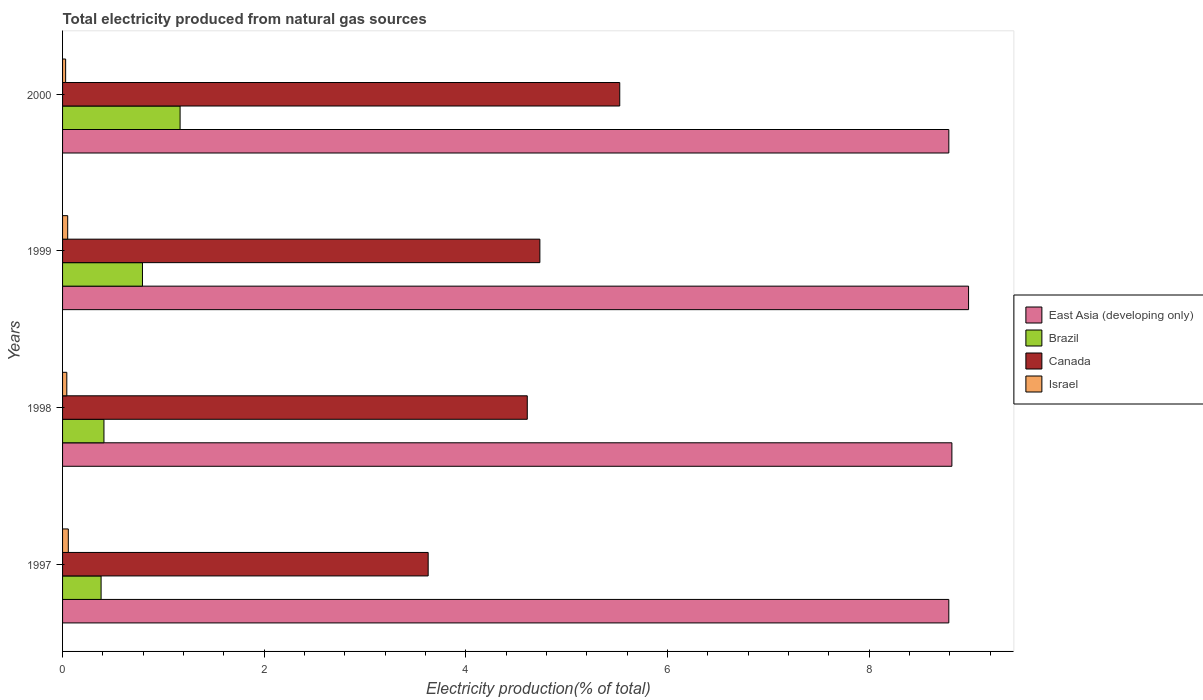How many different coloured bars are there?
Your answer should be compact. 4. How many groups of bars are there?
Your answer should be compact. 4. How many bars are there on the 3rd tick from the bottom?
Keep it short and to the point. 4. What is the total electricity produced in Canada in 1999?
Make the answer very short. 4.73. Across all years, what is the maximum total electricity produced in East Asia (developing only)?
Provide a short and direct response. 8.99. Across all years, what is the minimum total electricity produced in East Asia (developing only)?
Ensure brevity in your answer.  8.79. In which year was the total electricity produced in East Asia (developing only) maximum?
Your response must be concise. 1999. What is the total total electricity produced in Israel in the graph?
Ensure brevity in your answer.  0.18. What is the difference between the total electricity produced in Canada in 1998 and that in 1999?
Provide a succinct answer. -0.13. What is the difference between the total electricity produced in Israel in 1997 and the total electricity produced in Brazil in 1999?
Your response must be concise. -0.74. What is the average total electricity produced in Brazil per year?
Ensure brevity in your answer.  0.69. In the year 1997, what is the difference between the total electricity produced in Brazil and total electricity produced in East Asia (developing only)?
Make the answer very short. -8.41. In how many years, is the total electricity produced in Israel greater than 2 %?
Give a very brief answer. 0. What is the ratio of the total electricity produced in Brazil in 1999 to that in 2000?
Make the answer very short. 0.68. Is the difference between the total electricity produced in Brazil in 1997 and 1998 greater than the difference between the total electricity produced in East Asia (developing only) in 1997 and 1998?
Provide a short and direct response. Yes. What is the difference between the highest and the second highest total electricity produced in Brazil?
Make the answer very short. 0.37. What is the difference between the highest and the lowest total electricity produced in Canada?
Offer a very short reply. 1.9. In how many years, is the total electricity produced in Brazil greater than the average total electricity produced in Brazil taken over all years?
Give a very brief answer. 2. Is the sum of the total electricity produced in Canada in 1997 and 1999 greater than the maximum total electricity produced in Israel across all years?
Provide a short and direct response. Yes. Is it the case that in every year, the sum of the total electricity produced in Brazil and total electricity produced in Israel is greater than the sum of total electricity produced in East Asia (developing only) and total electricity produced in Canada?
Your answer should be compact. No. What does the 3rd bar from the top in 1997 represents?
Your response must be concise. Brazil. Is it the case that in every year, the sum of the total electricity produced in Brazil and total electricity produced in East Asia (developing only) is greater than the total electricity produced in Israel?
Provide a succinct answer. Yes. How many bars are there?
Make the answer very short. 16. Are all the bars in the graph horizontal?
Your answer should be compact. Yes. How many years are there in the graph?
Provide a succinct answer. 4. Are the values on the major ticks of X-axis written in scientific E-notation?
Your answer should be very brief. No. Does the graph contain grids?
Ensure brevity in your answer.  No. How many legend labels are there?
Keep it short and to the point. 4. How are the legend labels stacked?
Offer a terse response. Vertical. What is the title of the graph?
Provide a succinct answer. Total electricity produced from natural gas sources. What is the Electricity production(% of total) of East Asia (developing only) in 1997?
Ensure brevity in your answer.  8.79. What is the Electricity production(% of total) in Brazil in 1997?
Provide a short and direct response. 0.38. What is the Electricity production(% of total) of Canada in 1997?
Your answer should be very brief. 3.63. What is the Electricity production(% of total) of Israel in 1997?
Make the answer very short. 0.06. What is the Electricity production(% of total) of East Asia (developing only) in 1998?
Make the answer very short. 8.82. What is the Electricity production(% of total) in Brazil in 1998?
Your answer should be very brief. 0.41. What is the Electricity production(% of total) in Canada in 1998?
Give a very brief answer. 4.61. What is the Electricity production(% of total) in Israel in 1998?
Offer a terse response. 0.04. What is the Electricity production(% of total) in East Asia (developing only) in 1999?
Keep it short and to the point. 8.99. What is the Electricity production(% of total) in Brazil in 1999?
Keep it short and to the point. 0.79. What is the Electricity production(% of total) of Canada in 1999?
Offer a terse response. 4.73. What is the Electricity production(% of total) of Israel in 1999?
Keep it short and to the point. 0.05. What is the Electricity production(% of total) of East Asia (developing only) in 2000?
Offer a terse response. 8.79. What is the Electricity production(% of total) in Brazil in 2000?
Offer a very short reply. 1.17. What is the Electricity production(% of total) of Canada in 2000?
Provide a short and direct response. 5.53. What is the Electricity production(% of total) in Israel in 2000?
Ensure brevity in your answer.  0.03. Across all years, what is the maximum Electricity production(% of total) in East Asia (developing only)?
Give a very brief answer. 8.99. Across all years, what is the maximum Electricity production(% of total) of Brazil?
Your answer should be compact. 1.17. Across all years, what is the maximum Electricity production(% of total) of Canada?
Make the answer very short. 5.53. Across all years, what is the maximum Electricity production(% of total) of Israel?
Offer a very short reply. 0.06. Across all years, what is the minimum Electricity production(% of total) in East Asia (developing only)?
Give a very brief answer. 8.79. Across all years, what is the minimum Electricity production(% of total) of Brazil?
Ensure brevity in your answer.  0.38. Across all years, what is the minimum Electricity production(% of total) in Canada?
Offer a very short reply. 3.63. Across all years, what is the minimum Electricity production(% of total) of Israel?
Your response must be concise. 0.03. What is the total Electricity production(% of total) of East Asia (developing only) in the graph?
Your response must be concise. 35.39. What is the total Electricity production(% of total) in Brazil in the graph?
Offer a terse response. 2.75. What is the total Electricity production(% of total) in Canada in the graph?
Provide a succinct answer. 18.5. What is the total Electricity production(% of total) of Israel in the graph?
Keep it short and to the point. 0.18. What is the difference between the Electricity production(% of total) of East Asia (developing only) in 1997 and that in 1998?
Offer a terse response. -0.03. What is the difference between the Electricity production(% of total) of Brazil in 1997 and that in 1998?
Give a very brief answer. -0.03. What is the difference between the Electricity production(% of total) of Canada in 1997 and that in 1998?
Your response must be concise. -0.98. What is the difference between the Electricity production(% of total) in Israel in 1997 and that in 1998?
Provide a short and direct response. 0.01. What is the difference between the Electricity production(% of total) of East Asia (developing only) in 1997 and that in 1999?
Ensure brevity in your answer.  -0.2. What is the difference between the Electricity production(% of total) in Brazil in 1997 and that in 1999?
Your answer should be compact. -0.41. What is the difference between the Electricity production(% of total) in Canada in 1997 and that in 1999?
Provide a short and direct response. -1.11. What is the difference between the Electricity production(% of total) of Israel in 1997 and that in 1999?
Give a very brief answer. 0.01. What is the difference between the Electricity production(% of total) of East Asia (developing only) in 1997 and that in 2000?
Your answer should be very brief. -0. What is the difference between the Electricity production(% of total) in Brazil in 1997 and that in 2000?
Offer a very short reply. -0.78. What is the difference between the Electricity production(% of total) in Canada in 1997 and that in 2000?
Give a very brief answer. -1.9. What is the difference between the Electricity production(% of total) in Israel in 1997 and that in 2000?
Keep it short and to the point. 0.03. What is the difference between the Electricity production(% of total) in East Asia (developing only) in 1998 and that in 1999?
Your answer should be compact. -0.17. What is the difference between the Electricity production(% of total) of Brazil in 1998 and that in 1999?
Provide a succinct answer. -0.38. What is the difference between the Electricity production(% of total) of Canada in 1998 and that in 1999?
Provide a succinct answer. -0.12. What is the difference between the Electricity production(% of total) of Israel in 1998 and that in 1999?
Ensure brevity in your answer.  -0.01. What is the difference between the Electricity production(% of total) in East Asia (developing only) in 1998 and that in 2000?
Your answer should be very brief. 0.03. What is the difference between the Electricity production(% of total) in Brazil in 1998 and that in 2000?
Your response must be concise. -0.76. What is the difference between the Electricity production(% of total) of Canada in 1998 and that in 2000?
Your answer should be compact. -0.92. What is the difference between the Electricity production(% of total) of Israel in 1998 and that in 2000?
Provide a succinct answer. 0.01. What is the difference between the Electricity production(% of total) of East Asia (developing only) in 1999 and that in 2000?
Provide a short and direct response. 0.2. What is the difference between the Electricity production(% of total) of Brazil in 1999 and that in 2000?
Give a very brief answer. -0.37. What is the difference between the Electricity production(% of total) of Canada in 1999 and that in 2000?
Ensure brevity in your answer.  -0.79. What is the difference between the Electricity production(% of total) of Israel in 1999 and that in 2000?
Keep it short and to the point. 0.02. What is the difference between the Electricity production(% of total) of East Asia (developing only) in 1997 and the Electricity production(% of total) of Brazil in 1998?
Your answer should be compact. 8.38. What is the difference between the Electricity production(% of total) of East Asia (developing only) in 1997 and the Electricity production(% of total) of Canada in 1998?
Your answer should be compact. 4.18. What is the difference between the Electricity production(% of total) of East Asia (developing only) in 1997 and the Electricity production(% of total) of Israel in 1998?
Offer a very short reply. 8.75. What is the difference between the Electricity production(% of total) of Brazil in 1997 and the Electricity production(% of total) of Canada in 1998?
Offer a terse response. -4.23. What is the difference between the Electricity production(% of total) of Brazil in 1997 and the Electricity production(% of total) of Israel in 1998?
Your answer should be very brief. 0.34. What is the difference between the Electricity production(% of total) of Canada in 1997 and the Electricity production(% of total) of Israel in 1998?
Offer a terse response. 3.58. What is the difference between the Electricity production(% of total) of East Asia (developing only) in 1997 and the Electricity production(% of total) of Brazil in 1999?
Offer a terse response. 8. What is the difference between the Electricity production(% of total) of East Asia (developing only) in 1997 and the Electricity production(% of total) of Canada in 1999?
Your response must be concise. 4.06. What is the difference between the Electricity production(% of total) in East Asia (developing only) in 1997 and the Electricity production(% of total) in Israel in 1999?
Give a very brief answer. 8.74. What is the difference between the Electricity production(% of total) in Brazil in 1997 and the Electricity production(% of total) in Canada in 1999?
Ensure brevity in your answer.  -4.35. What is the difference between the Electricity production(% of total) of Brazil in 1997 and the Electricity production(% of total) of Israel in 1999?
Offer a terse response. 0.33. What is the difference between the Electricity production(% of total) of Canada in 1997 and the Electricity production(% of total) of Israel in 1999?
Keep it short and to the point. 3.58. What is the difference between the Electricity production(% of total) in East Asia (developing only) in 1997 and the Electricity production(% of total) in Brazil in 2000?
Provide a succinct answer. 7.63. What is the difference between the Electricity production(% of total) of East Asia (developing only) in 1997 and the Electricity production(% of total) of Canada in 2000?
Provide a succinct answer. 3.26. What is the difference between the Electricity production(% of total) of East Asia (developing only) in 1997 and the Electricity production(% of total) of Israel in 2000?
Your answer should be very brief. 8.76. What is the difference between the Electricity production(% of total) in Brazil in 1997 and the Electricity production(% of total) in Canada in 2000?
Offer a terse response. -5.14. What is the difference between the Electricity production(% of total) of Brazil in 1997 and the Electricity production(% of total) of Israel in 2000?
Ensure brevity in your answer.  0.35. What is the difference between the Electricity production(% of total) in Canada in 1997 and the Electricity production(% of total) in Israel in 2000?
Keep it short and to the point. 3.6. What is the difference between the Electricity production(% of total) in East Asia (developing only) in 1998 and the Electricity production(% of total) in Brazil in 1999?
Ensure brevity in your answer.  8.03. What is the difference between the Electricity production(% of total) of East Asia (developing only) in 1998 and the Electricity production(% of total) of Canada in 1999?
Your answer should be very brief. 4.09. What is the difference between the Electricity production(% of total) in East Asia (developing only) in 1998 and the Electricity production(% of total) in Israel in 1999?
Provide a short and direct response. 8.77. What is the difference between the Electricity production(% of total) of Brazil in 1998 and the Electricity production(% of total) of Canada in 1999?
Give a very brief answer. -4.32. What is the difference between the Electricity production(% of total) of Brazil in 1998 and the Electricity production(% of total) of Israel in 1999?
Your answer should be very brief. 0.36. What is the difference between the Electricity production(% of total) of Canada in 1998 and the Electricity production(% of total) of Israel in 1999?
Provide a short and direct response. 4.56. What is the difference between the Electricity production(% of total) in East Asia (developing only) in 1998 and the Electricity production(% of total) in Brazil in 2000?
Your answer should be very brief. 7.66. What is the difference between the Electricity production(% of total) in East Asia (developing only) in 1998 and the Electricity production(% of total) in Canada in 2000?
Provide a succinct answer. 3.29. What is the difference between the Electricity production(% of total) in East Asia (developing only) in 1998 and the Electricity production(% of total) in Israel in 2000?
Ensure brevity in your answer.  8.79. What is the difference between the Electricity production(% of total) in Brazil in 1998 and the Electricity production(% of total) in Canada in 2000?
Offer a terse response. -5.12. What is the difference between the Electricity production(% of total) of Brazil in 1998 and the Electricity production(% of total) of Israel in 2000?
Keep it short and to the point. 0.38. What is the difference between the Electricity production(% of total) in Canada in 1998 and the Electricity production(% of total) in Israel in 2000?
Your answer should be compact. 4.58. What is the difference between the Electricity production(% of total) of East Asia (developing only) in 1999 and the Electricity production(% of total) of Brazil in 2000?
Make the answer very short. 7.82. What is the difference between the Electricity production(% of total) of East Asia (developing only) in 1999 and the Electricity production(% of total) of Canada in 2000?
Ensure brevity in your answer.  3.46. What is the difference between the Electricity production(% of total) of East Asia (developing only) in 1999 and the Electricity production(% of total) of Israel in 2000?
Make the answer very short. 8.96. What is the difference between the Electricity production(% of total) of Brazil in 1999 and the Electricity production(% of total) of Canada in 2000?
Your response must be concise. -4.73. What is the difference between the Electricity production(% of total) of Brazil in 1999 and the Electricity production(% of total) of Israel in 2000?
Provide a short and direct response. 0.76. What is the difference between the Electricity production(% of total) in Canada in 1999 and the Electricity production(% of total) in Israel in 2000?
Make the answer very short. 4.7. What is the average Electricity production(% of total) in East Asia (developing only) per year?
Offer a terse response. 8.85. What is the average Electricity production(% of total) in Brazil per year?
Make the answer very short. 0.69. What is the average Electricity production(% of total) in Canada per year?
Provide a succinct answer. 4.62. What is the average Electricity production(% of total) of Israel per year?
Your answer should be very brief. 0.05. In the year 1997, what is the difference between the Electricity production(% of total) of East Asia (developing only) and Electricity production(% of total) of Brazil?
Make the answer very short. 8.41. In the year 1997, what is the difference between the Electricity production(% of total) of East Asia (developing only) and Electricity production(% of total) of Canada?
Your response must be concise. 5.16. In the year 1997, what is the difference between the Electricity production(% of total) in East Asia (developing only) and Electricity production(% of total) in Israel?
Provide a succinct answer. 8.73. In the year 1997, what is the difference between the Electricity production(% of total) of Brazil and Electricity production(% of total) of Canada?
Give a very brief answer. -3.24. In the year 1997, what is the difference between the Electricity production(% of total) in Brazil and Electricity production(% of total) in Israel?
Provide a short and direct response. 0.33. In the year 1997, what is the difference between the Electricity production(% of total) in Canada and Electricity production(% of total) in Israel?
Keep it short and to the point. 3.57. In the year 1998, what is the difference between the Electricity production(% of total) in East Asia (developing only) and Electricity production(% of total) in Brazil?
Your response must be concise. 8.41. In the year 1998, what is the difference between the Electricity production(% of total) of East Asia (developing only) and Electricity production(% of total) of Canada?
Keep it short and to the point. 4.21. In the year 1998, what is the difference between the Electricity production(% of total) in East Asia (developing only) and Electricity production(% of total) in Israel?
Your answer should be very brief. 8.78. In the year 1998, what is the difference between the Electricity production(% of total) in Brazil and Electricity production(% of total) in Canada?
Ensure brevity in your answer.  -4.2. In the year 1998, what is the difference between the Electricity production(% of total) in Brazil and Electricity production(% of total) in Israel?
Ensure brevity in your answer.  0.37. In the year 1998, what is the difference between the Electricity production(% of total) in Canada and Electricity production(% of total) in Israel?
Your answer should be compact. 4.57. In the year 1999, what is the difference between the Electricity production(% of total) in East Asia (developing only) and Electricity production(% of total) in Brazil?
Ensure brevity in your answer.  8.19. In the year 1999, what is the difference between the Electricity production(% of total) of East Asia (developing only) and Electricity production(% of total) of Canada?
Offer a terse response. 4.25. In the year 1999, what is the difference between the Electricity production(% of total) in East Asia (developing only) and Electricity production(% of total) in Israel?
Make the answer very short. 8.94. In the year 1999, what is the difference between the Electricity production(% of total) of Brazil and Electricity production(% of total) of Canada?
Provide a short and direct response. -3.94. In the year 1999, what is the difference between the Electricity production(% of total) of Brazil and Electricity production(% of total) of Israel?
Your answer should be compact. 0.74. In the year 1999, what is the difference between the Electricity production(% of total) in Canada and Electricity production(% of total) in Israel?
Offer a very short reply. 4.68. In the year 2000, what is the difference between the Electricity production(% of total) of East Asia (developing only) and Electricity production(% of total) of Brazil?
Provide a short and direct response. 7.63. In the year 2000, what is the difference between the Electricity production(% of total) in East Asia (developing only) and Electricity production(% of total) in Canada?
Offer a terse response. 3.26. In the year 2000, what is the difference between the Electricity production(% of total) of East Asia (developing only) and Electricity production(% of total) of Israel?
Provide a succinct answer. 8.76. In the year 2000, what is the difference between the Electricity production(% of total) in Brazil and Electricity production(% of total) in Canada?
Make the answer very short. -4.36. In the year 2000, what is the difference between the Electricity production(% of total) of Brazil and Electricity production(% of total) of Israel?
Keep it short and to the point. 1.14. In the year 2000, what is the difference between the Electricity production(% of total) of Canada and Electricity production(% of total) of Israel?
Provide a succinct answer. 5.5. What is the ratio of the Electricity production(% of total) in Brazil in 1997 to that in 1998?
Provide a short and direct response. 0.93. What is the ratio of the Electricity production(% of total) of Canada in 1997 to that in 1998?
Make the answer very short. 0.79. What is the ratio of the Electricity production(% of total) in Israel in 1997 to that in 1998?
Give a very brief answer. 1.35. What is the ratio of the Electricity production(% of total) of East Asia (developing only) in 1997 to that in 1999?
Your response must be concise. 0.98. What is the ratio of the Electricity production(% of total) in Brazil in 1997 to that in 1999?
Your answer should be very brief. 0.48. What is the ratio of the Electricity production(% of total) of Canada in 1997 to that in 1999?
Offer a very short reply. 0.77. What is the ratio of the Electricity production(% of total) in Israel in 1997 to that in 1999?
Provide a short and direct response. 1.12. What is the ratio of the Electricity production(% of total) of East Asia (developing only) in 1997 to that in 2000?
Ensure brevity in your answer.  1. What is the ratio of the Electricity production(% of total) of Brazil in 1997 to that in 2000?
Make the answer very short. 0.33. What is the ratio of the Electricity production(% of total) in Canada in 1997 to that in 2000?
Your answer should be very brief. 0.66. What is the ratio of the Electricity production(% of total) of Israel in 1997 to that in 2000?
Keep it short and to the point. 1.87. What is the ratio of the Electricity production(% of total) of East Asia (developing only) in 1998 to that in 1999?
Your answer should be very brief. 0.98. What is the ratio of the Electricity production(% of total) in Brazil in 1998 to that in 1999?
Make the answer very short. 0.52. What is the ratio of the Electricity production(% of total) of Canada in 1998 to that in 1999?
Your answer should be very brief. 0.97. What is the ratio of the Electricity production(% of total) in Israel in 1998 to that in 1999?
Offer a terse response. 0.83. What is the ratio of the Electricity production(% of total) in Brazil in 1998 to that in 2000?
Your answer should be very brief. 0.35. What is the ratio of the Electricity production(% of total) of Canada in 1998 to that in 2000?
Your answer should be very brief. 0.83. What is the ratio of the Electricity production(% of total) in Israel in 1998 to that in 2000?
Give a very brief answer. 1.38. What is the ratio of the Electricity production(% of total) of East Asia (developing only) in 1999 to that in 2000?
Your answer should be compact. 1.02. What is the ratio of the Electricity production(% of total) in Brazil in 1999 to that in 2000?
Your answer should be very brief. 0.68. What is the ratio of the Electricity production(% of total) in Canada in 1999 to that in 2000?
Make the answer very short. 0.86. What is the ratio of the Electricity production(% of total) of Israel in 1999 to that in 2000?
Offer a very short reply. 1.67. What is the difference between the highest and the second highest Electricity production(% of total) of East Asia (developing only)?
Your answer should be compact. 0.17. What is the difference between the highest and the second highest Electricity production(% of total) of Brazil?
Provide a succinct answer. 0.37. What is the difference between the highest and the second highest Electricity production(% of total) of Canada?
Ensure brevity in your answer.  0.79. What is the difference between the highest and the second highest Electricity production(% of total) of Israel?
Give a very brief answer. 0.01. What is the difference between the highest and the lowest Electricity production(% of total) in East Asia (developing only)?
Provide a short and direct response. 0.2. What is the difference between the highest and the lowest Electricity production(% of total) in Brazil?
Ensure brevity in your answer.  0.78. What is the difference between the highest and the lowest Electricity production(% of total) of Canada?
Offer a terse response. 1.9. What is the difference between the highest and the lowest Electricity production(% of total) of Israel?
Give a very brief answer. 0.03. 